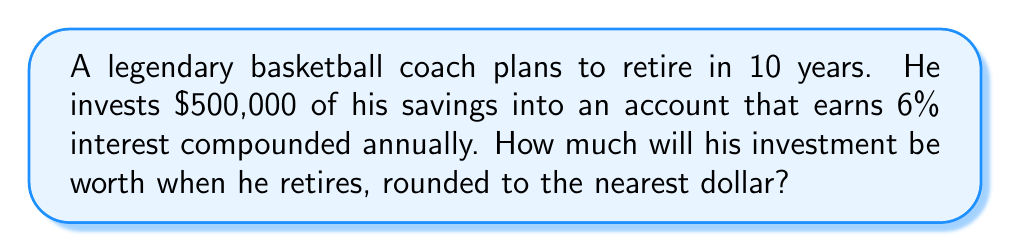Help me with this question. To solve this problem, we'll use the compound interest formula:

$$A = P(1 + r)^n$$

Where:
$A$ = final amount
$P$ = principal (initial investment)
$r$ = annual interest rate (as a decimal)
$n$ = number of years

Given:
$P = \$500,000$
$r = 0.06$ (6% expressed as a decimal)
$n = 10$ years

Let's plug these values into the formula:

$$A = 500,000(1 + 0.06)^{10}$$

Now, let's calculate step-by-step:

1. Calculate $(1 + 0.06)^{10}$:
   $$(1.06)^{10} \approx 1.7908$$

2. Multiply the result by the principal:
   $$500,000 \times 1.7908 \approx 895,423.97$$

3. Round to the nearest dollar:
   $$895,423.97 \approx \$895,424$$

Therefore, the coach's investment will be worth $895,424 when he retires in 10 years.
Answer: $895,424 